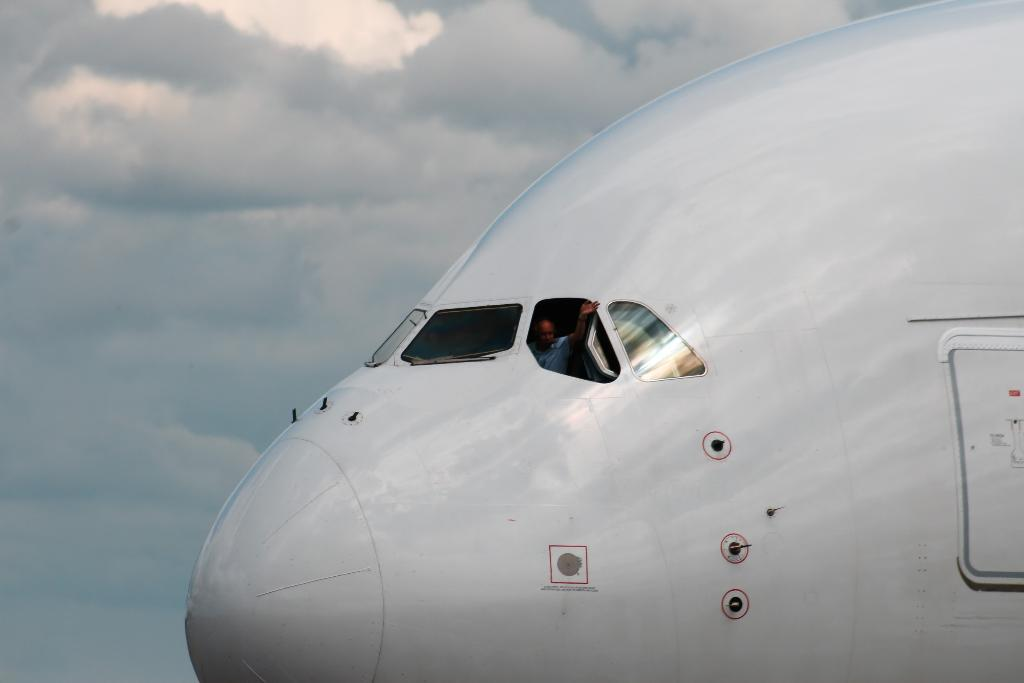What is the main subject of the image? The main subject of the image is the front part of an airplane. Can you describe the interior of the airplane? There is a person sitting inside the airplane. What can be seen in the background of the image? The sky with clouds is visible in the background of the image. What direction is the airplane's nose pointing in the image? The facts provided do not specify the direction the airplane's nose is pointing, so we cannot definitively answer this question. --- 